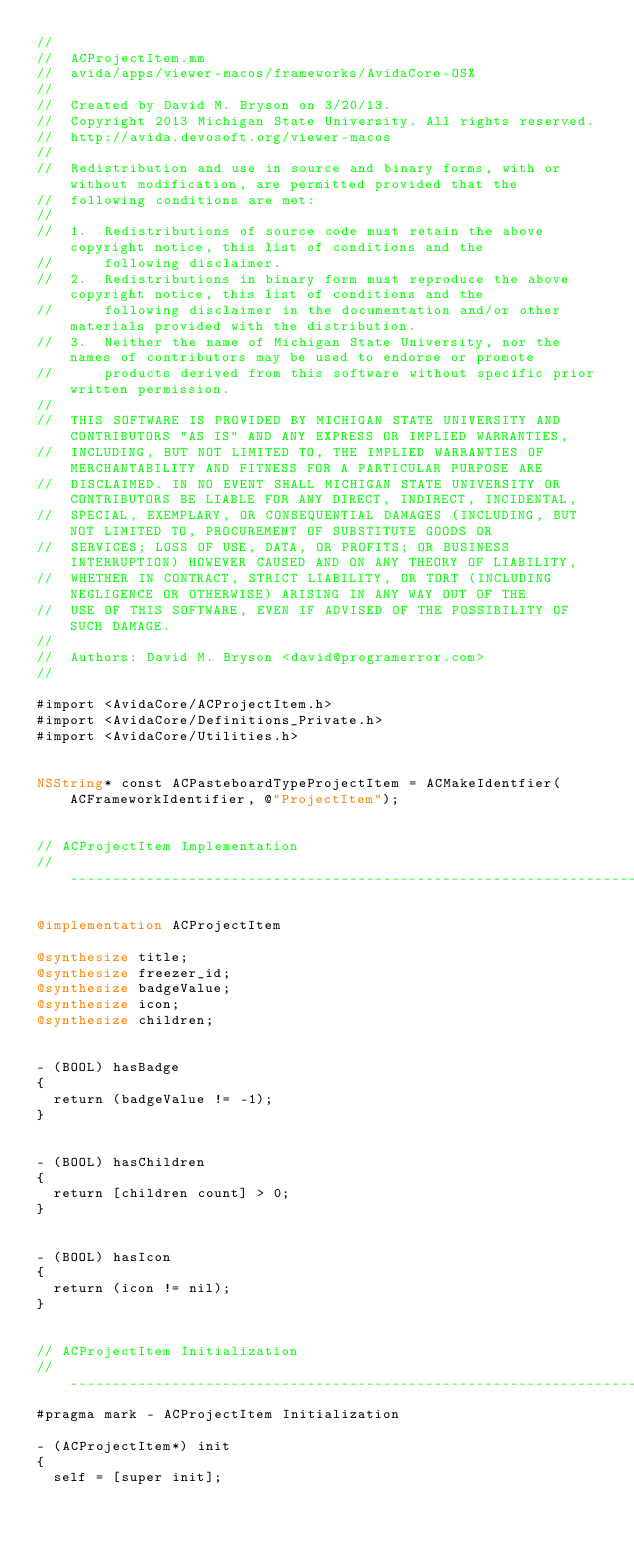Convert code to text. <code><loc_0><loc_0><loc_500><loc_500><_ObjectiveC_>//
//  ACProjectItem.mm
//  avida/apps/viewer-macos/frameworks/AvidaCore-OSX
//
//  Created by David M. Bryson on 3/20/13.
//  Copyright 2013 Michigan State University. All rights reserved.
//  http://avida.devosoft.org/viewer-macos
//
//  Redistribution and use in source and binary forms, with or without modification, are permitted provided that the
//  following conditions are met:
//
//  1.  Redistributions of source code must retain the above copyright notice, this list of conditions and the
//      following disclaimer.
//  2.  Redistributions in binary form must reproduce the above copyright notice, this list of conditions and the
//      following disclaimer in the documentation and/or other materials provided with the distribution.
//  3.  Neither the name of Michigan State University, nor the names of contributors may be used to endorse or promote
//      products derived from this software without specific prior written permission.
//
//  THIS SOFTWARE IS PROVIDED BY MICHIGAN STATE UNIVERSITY AND CONTRIBUTORS "AS IS" AND ANY EXPRESS OR IMPLIED WARRANTIES,
//  INCLUDING, BUT NOT LIMITED TO, THE IMPLIED WARRANTIES OF MERCHANTABILITY AND FITNESS FOR A PARTICULAR PURPOSE ARE
//  DISCLAIMED. IN NO EVENT SHALL MICHIGAN STATE UNIVERSITY OR CONTRIBUTORS BE LIABLE FOR ANY DIRECT, INDIRECT, INCIDENTAL,
//  SPECIAL, EXEMPLARY, OR CONSEQUENTIAL DAMAGES (INCLUDING, BUT NOT LIMITED TO, PROCUREMENT OF SUBSTITUTE GOODS OR
//  SERVICES; LOSS OF USE, DATA, OR PROFITS; OR BUSINESS INTERRUPTION) HOWEVER CAUSED AND ON ANY THEORY OF LIABILITY,
//  WHETHER IN CONTRACT, STRICT LIABILITY, OR TORT (INCLUDING NEGLIGENCE OR OTHERWISE) ARISING IN ANY WAY OUT OF THE
//  USE OF THIS SOFTWARE, EVEN IF ADVISED OF THE POSSIBILITY OF SUCH DAMAGE.
//
//  Authors: David M. Bryson <david@programerror.com>
//

#import <AvidaCore/ACProjectItem.h>
#import <AvidaCore/Definitions_Private.h>
#import <AvidaCore/Utilities.h>


NSString* const ACPasteboardTypeProjectItem = ACMakeIdentfier(ACFrameworkIdentifier, @"ProjectItem");


// ACProjectItem Implementation
// --------------------------------------------------------------------------------------------------------------

@implementation ACProjectItem

@synthesize title;
@synthesize freezer_id;
@synthesize badgeValue;
@synthesize icon;
@synthesize children;


- (BOOL) hasBadge
{
  return (badgeValue != -1);
}


- (BOOL) hasChildren
{
  return [children count] > 0;
}


- (BOOL) hasIcon
{
  return (icon != nil);
}


// ACProjectItem Initialization
// --------------------------------------------------------------------------------------------------------------
#pragma mark - ACProjectItem Initialization

- (ACProjectItem*) init
{
  self = [super init];
  </code> 